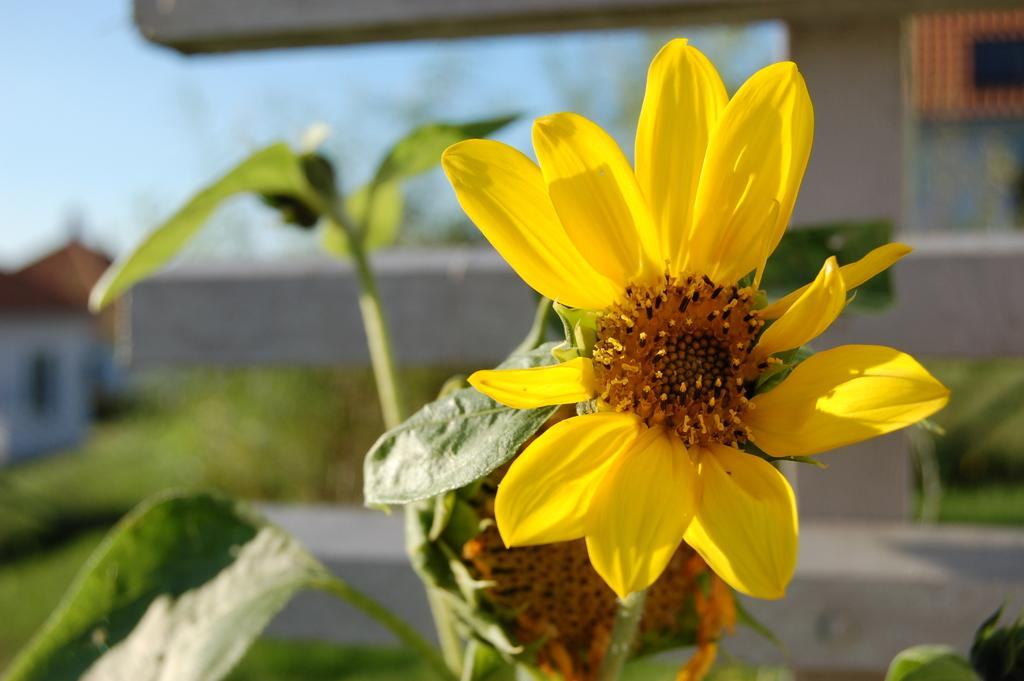What type of plant is featured in the image? There is a yellow flower and green leaves in the image. What color is the flower? The flower is yellow. What can be seen in the background of the image? The background of the image includes buildings. How is the background of the image depicted? The background is blurred. How many sacks are being used to carry the tax in the image? There is no mention of sacks or tax in the image; it features a yellow flower and green leaves with a blurred background of buildings. 